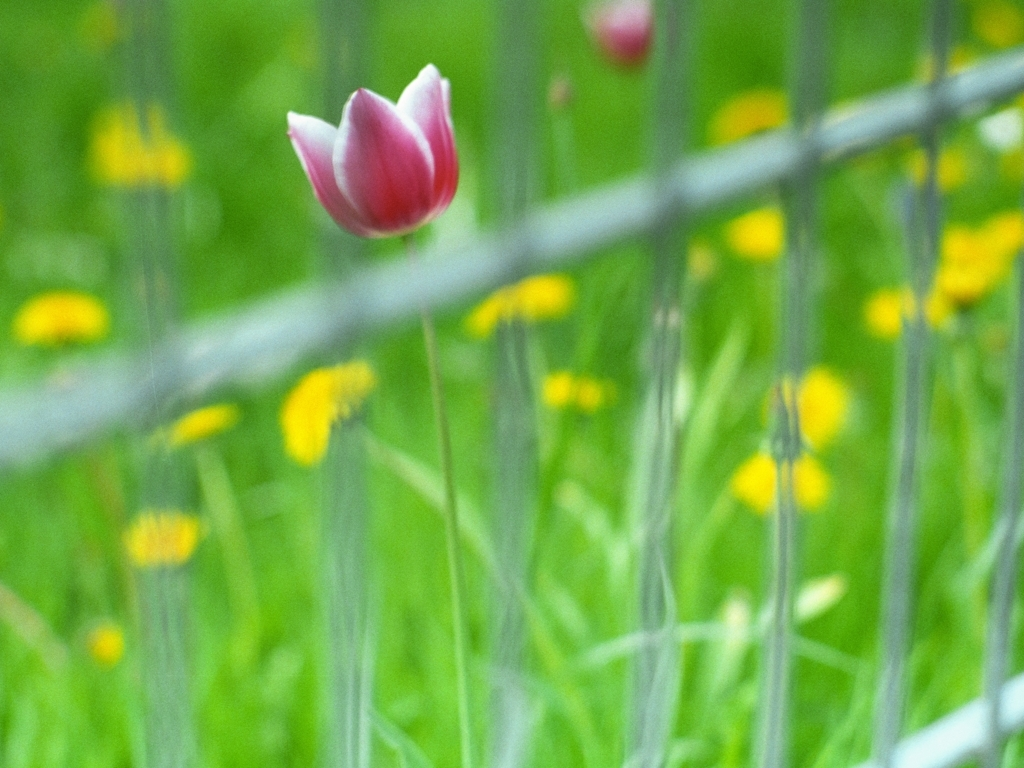How might the wire fence in the image symbolically relate to the tulip? Symbolically, the wire fence could represent a barrier or boundary that the tulip has managed to grow beside, or perhaps overcome. It might suggest themes of resilience, growth in the face of obstacles, and the beauty of nature standing out in contrast to the man-made structures that contain it. 